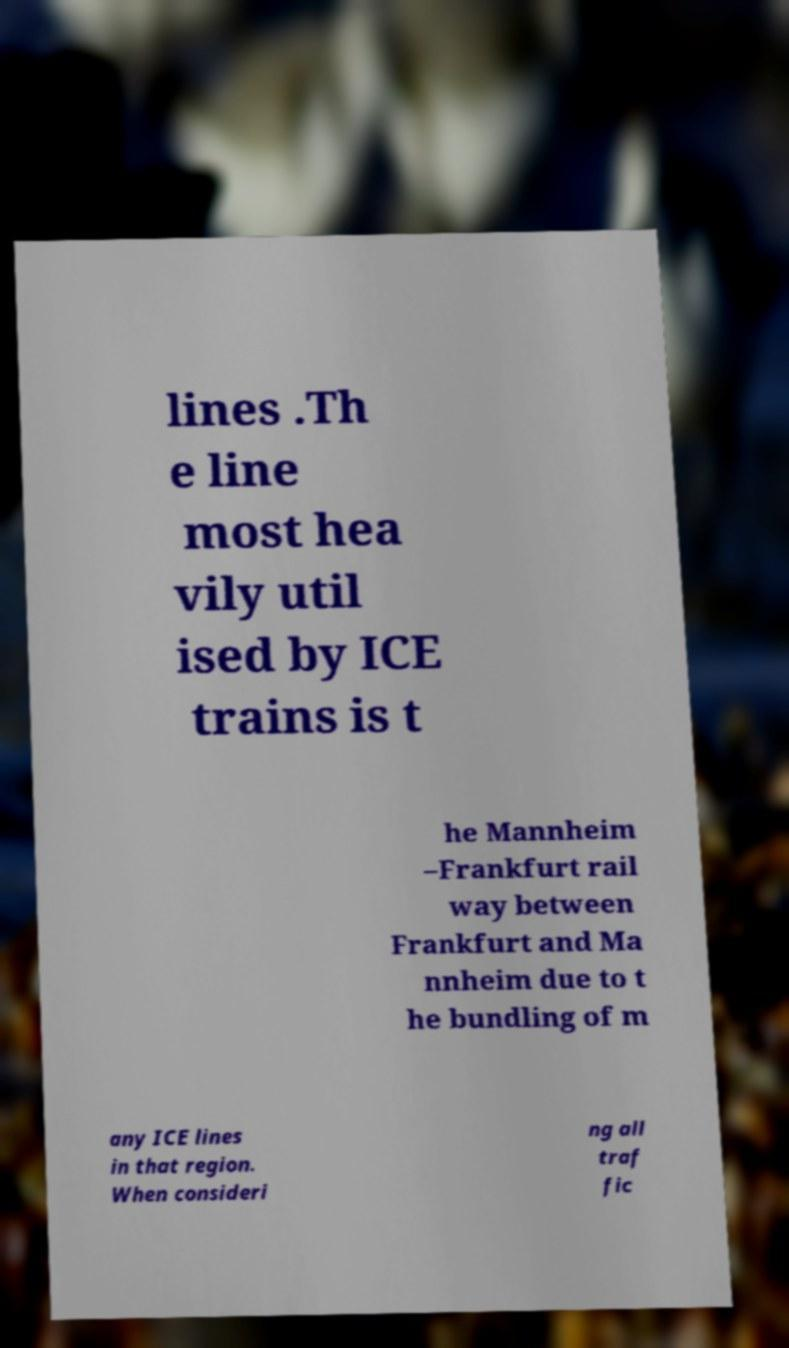I need the written content from this picture converted into text. Can you do that? lines .Th e line most hea vily util ised by ICE trains is t he Mannheim –Frankfurt rail way between Frankfurt and Ma nnheim due to t he bundling of m any ICE lines in that region. When consideri ng all traf fic 